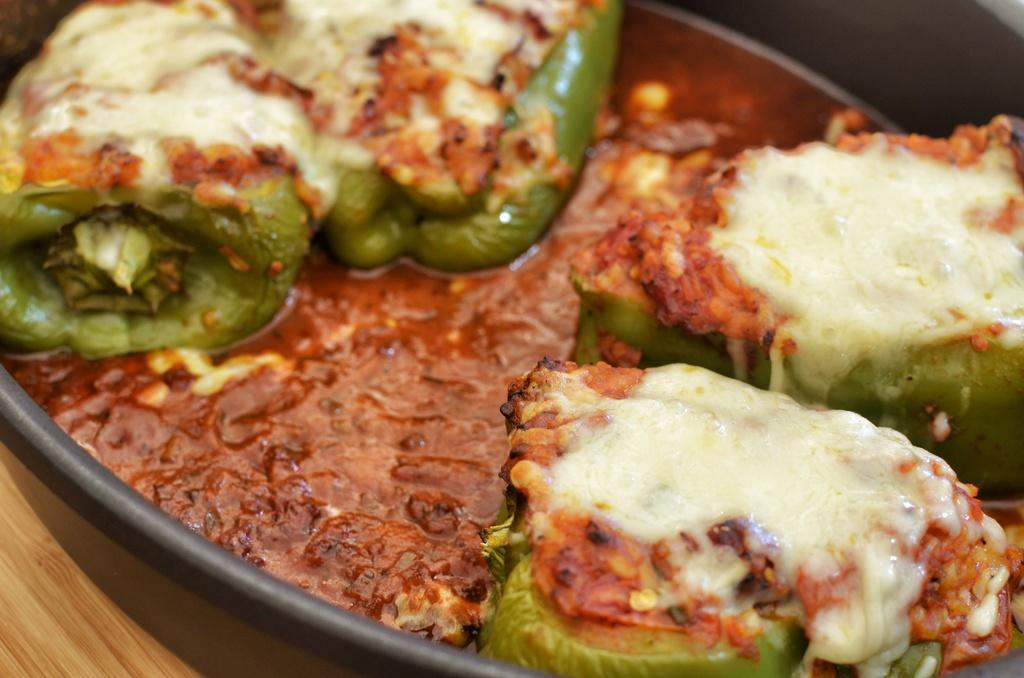What is the main subject of the image? There is a food item in the image. How is the food item contained in the image? The food item is in a bowl. Where is the bowl placed in the image? The bowl is placed on a table. What type of cow can be seen blowing on the food item in the image? There is no cow or blowing action present in the image. 